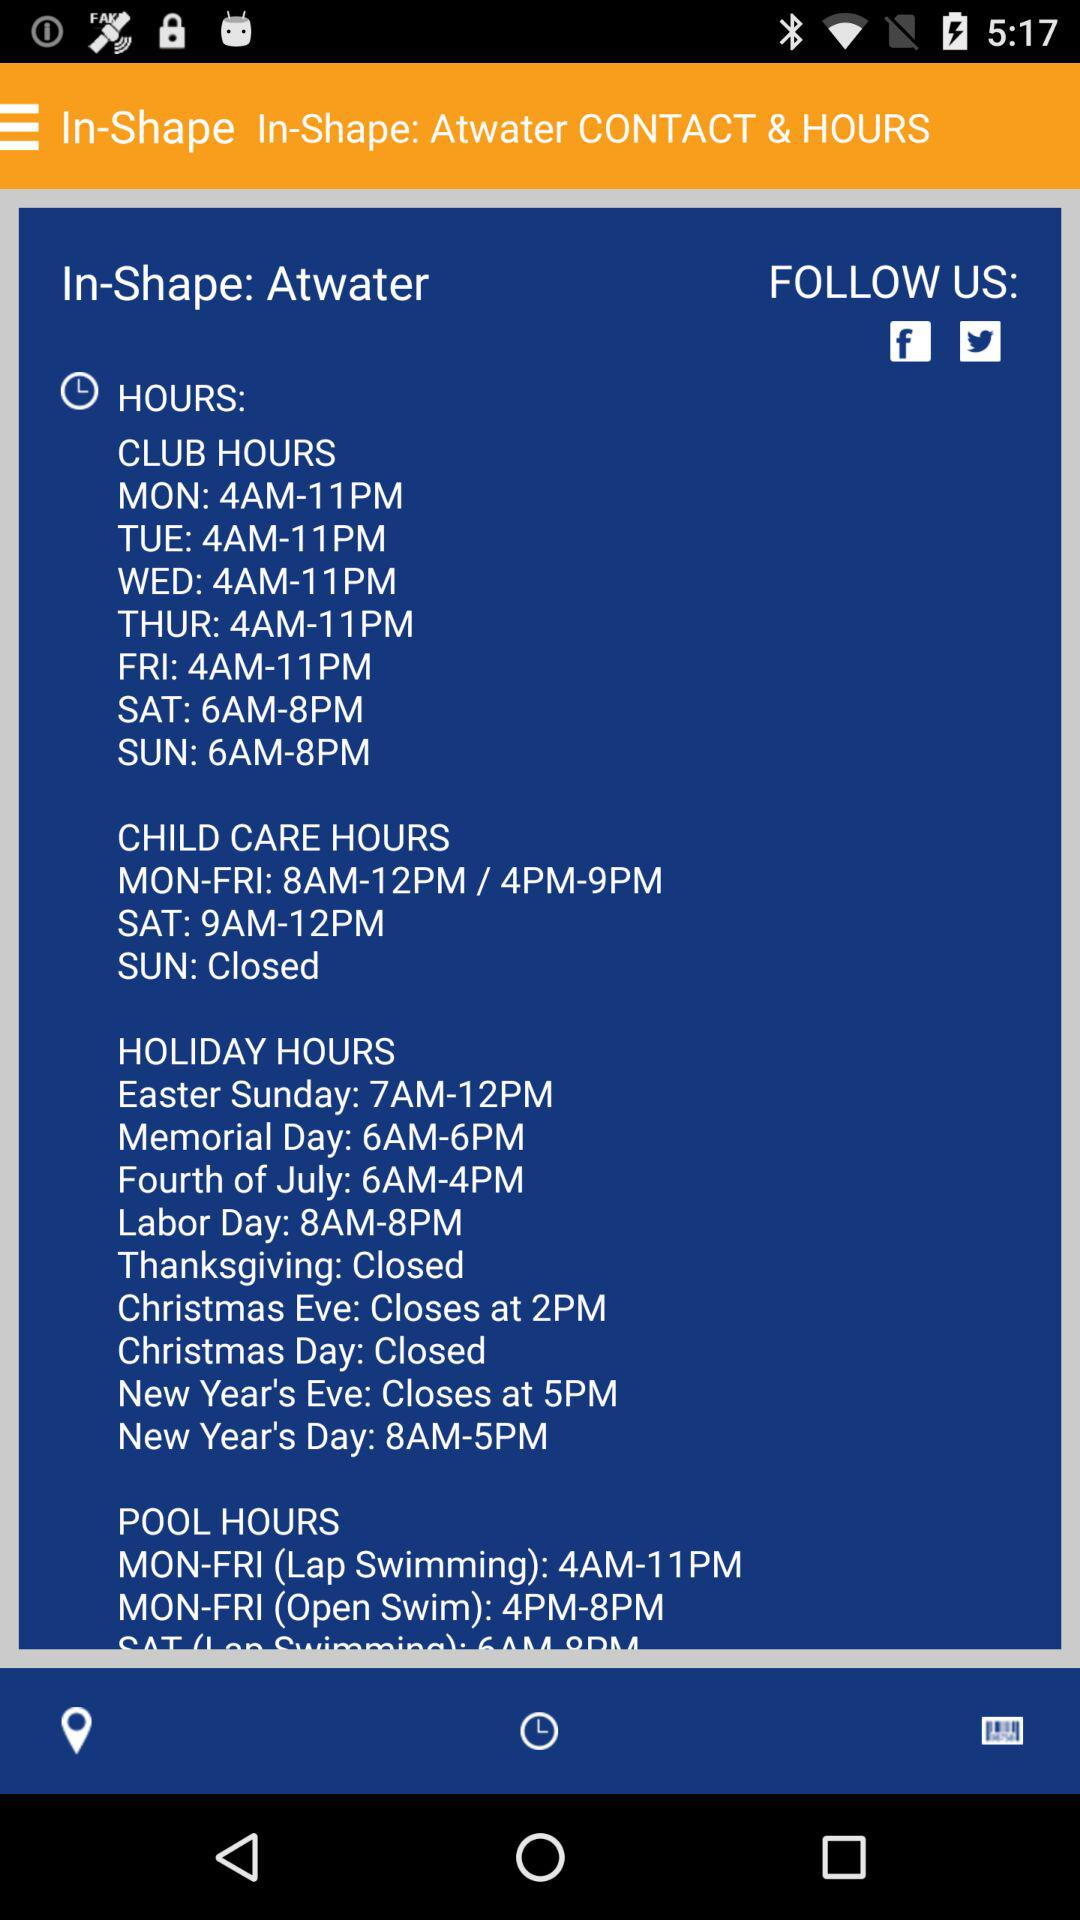Where can we follow it? You can follow it on "Facebook" and "Twitter". 